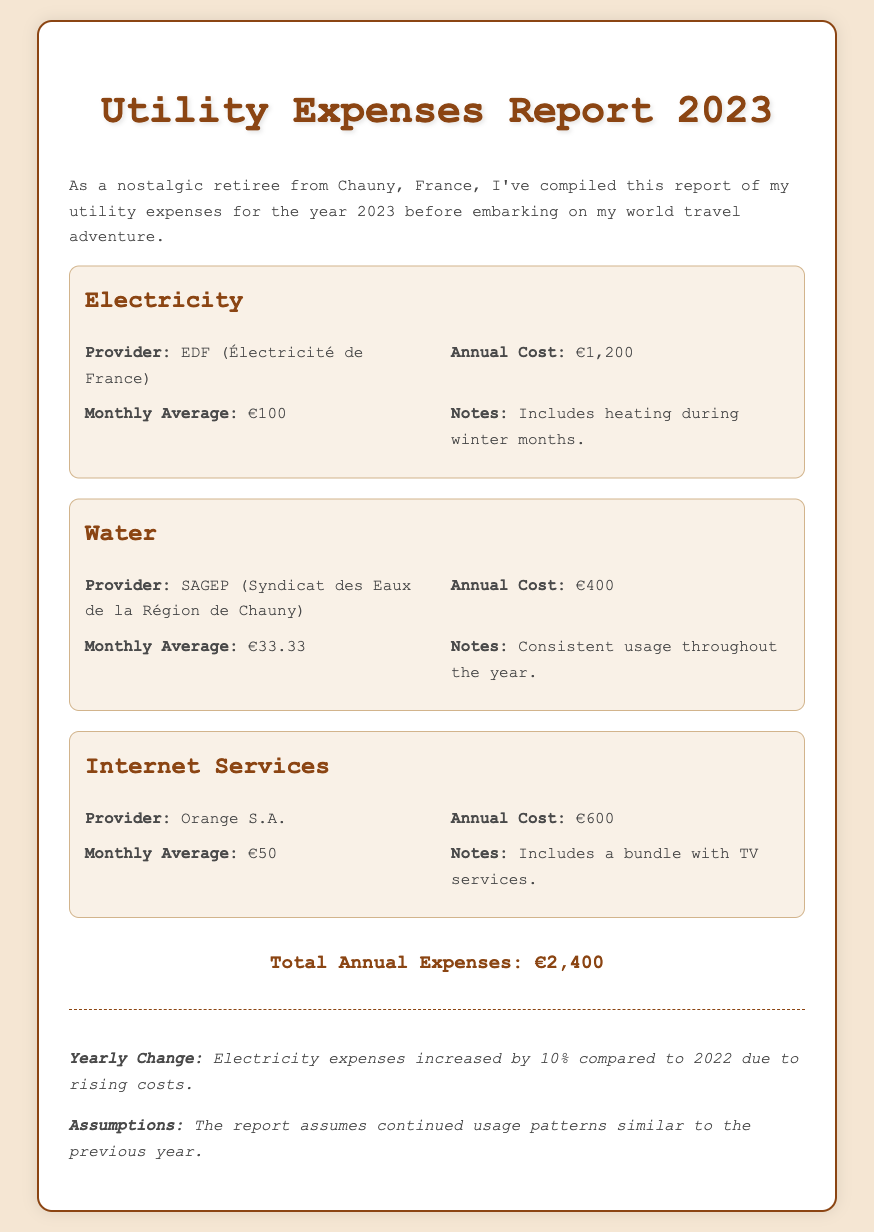What is the total annual cost for electricity? The total annual cost for electricity is stated in the document under the Electricity section as €1,200.
Answer: €1,200 Who is the internet services provider? The provider for internet services is mentioned in the Internet Services section as Orange S.A.
Answer: Orange S.A What was the monthly average cost for water? The monthly average cost for water can be found in the Water section as €33.33.
Answer: €33.33 What percentage increase did electricity expenses experience compared to 2022? The document notes that electricity expenses increased by 10% compared to the previous year.
Answer: 10% What is the annual cost for Internet services? The annual cost for Internet services is provided in the Internet Services section as €600.
Answer: €600 What is the total annual expense for all utilities? The total annual expenses for all utilities is summarized in the document as €2,400.
Answer: €2,400 What is included in the electricity cost notes? The notes for electricity include that it covers heating during winter months.
Answer: Heating during winter months How often was water usage consistent throughout the year? The notes in the Water section state that usage was consistent throughout the year.
Answer: Consistent throughout the year What additional service is included with the internet bundle? The document specifies that TV services are included with the internet bundle.
Answer: TV services 